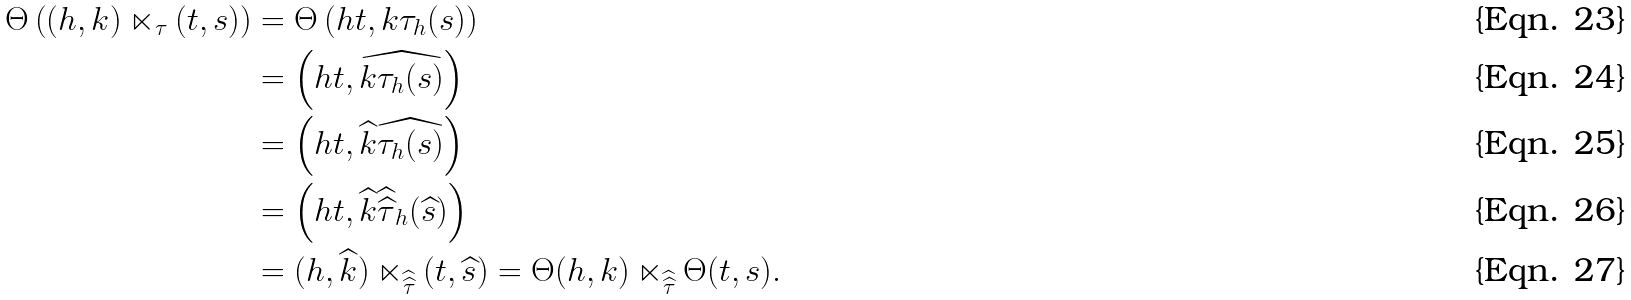Convert formula to latex. <formula><loc_0><loc_0><loc_500><loc_500>\Theta \left ( ( h , k ) \ltimes _ { \tau } ( t , s ) \right ) & = \Theta \left ( h t , k \tau _ { h } ( s ) \right ) \\ & = \left ( h t , \widehat { k \tau _ { h } ( s ) } \right ) \\ & = \left ( h t , \widehat { k } \widehat { \tau _ { h } ( s ) } \right ) \\ & = \left ( h t , \widehat { k } { \widehat { \widehat { \tau } } } _ { h } ( \widehat { s } ) \right ) \\ & = ( h , \widehat { k } ) \ltimes _ { \widehat { \widehat { \tau } } } ( t , \widehat { s } ) = \Theta ( h , k ) \ltimes _ { \widehat { \widehat { \tau } } } \Theta ( t , s ) .</formula> 